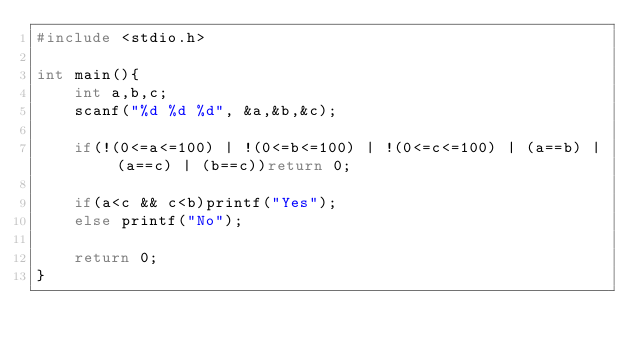<code> <loc_0><loc_0><loc_500><loc_500><_C_>#include <stdio.h>

int main(){
    int a,b,c;
    scanf("%d %d %d", &a,&b,&c);

    if(!(0<=a<=100) | !(0<=b<=100) | !(0<=c<=100) | (a==b) | (a==c) | (b==c))return 0;

    if(a<c && c<b)printf("Yes");
    else printf("No");

    return 0;
}</code> 